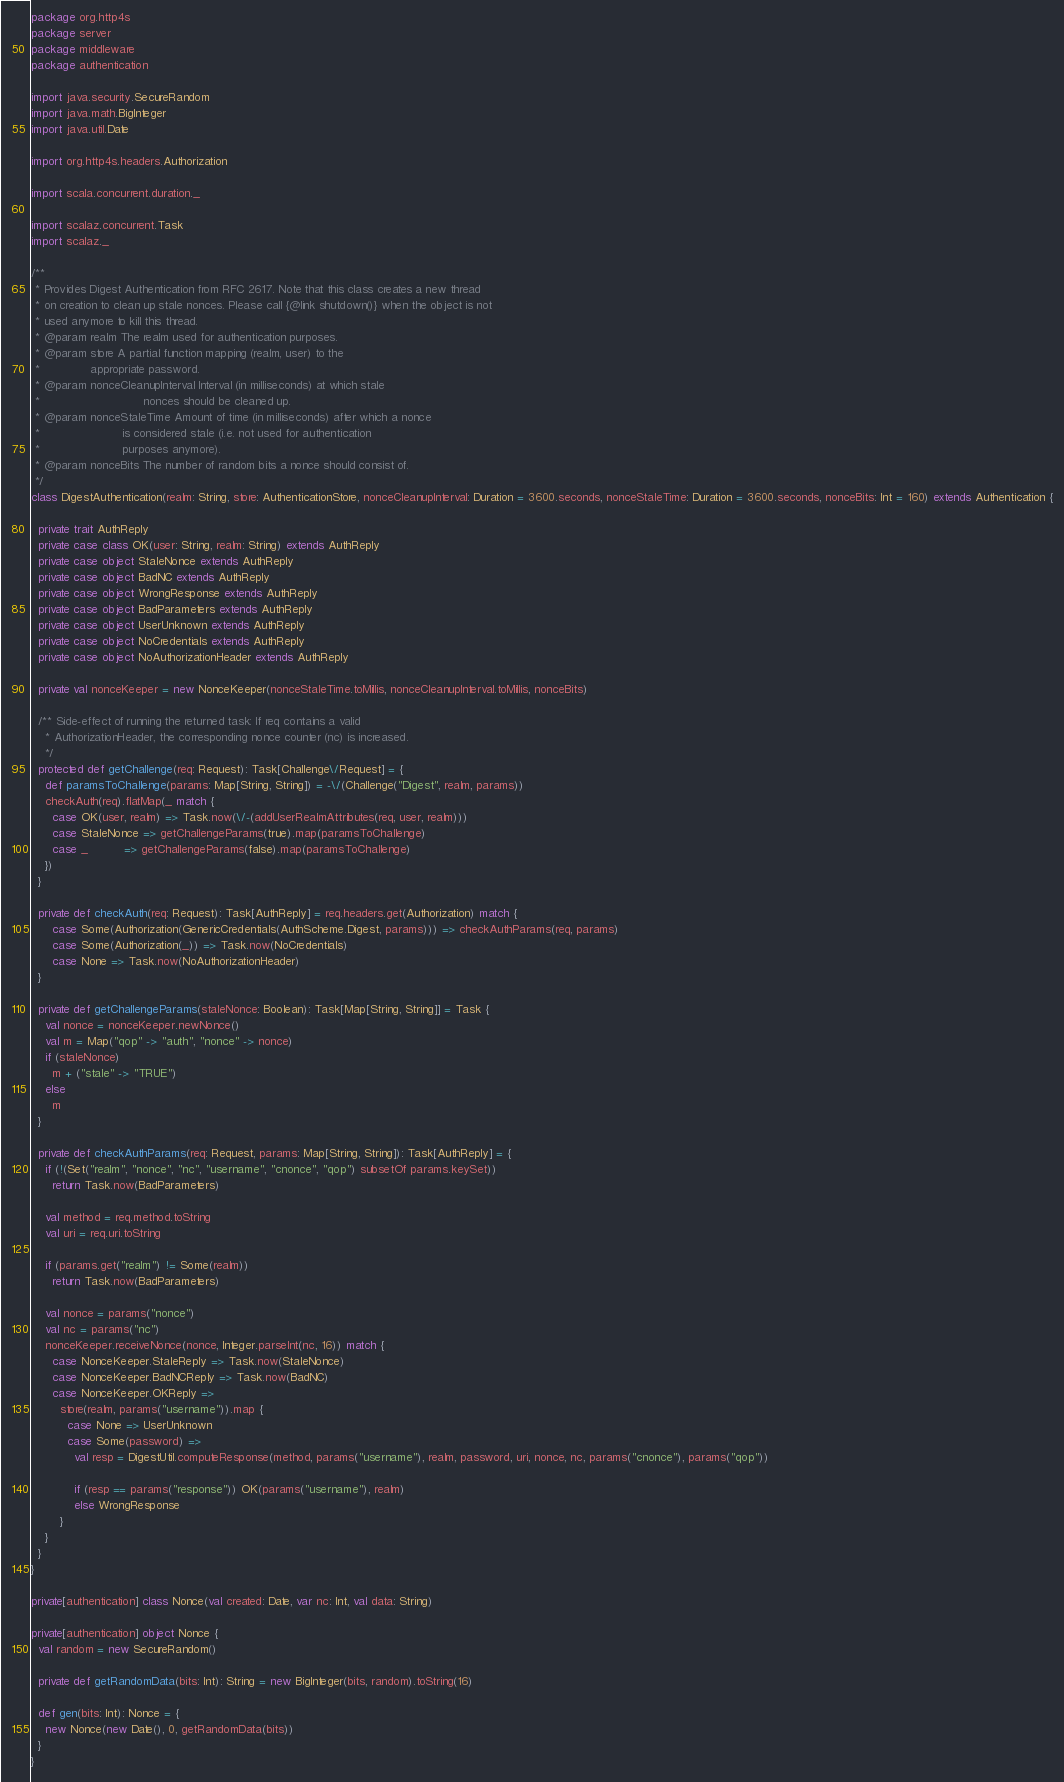<code> <loc_0><loc_0><loc_500><loc_500><_Scala_>package org.http4s
package server
package middleware
package authentication

import java.security.SecureRandom
import java.math.BigInteger
import java.util.Date

import org.http4s.headers.Authorization

import scala.concurrent.duration._

import scalaz.concurrent.Task
import scalaz._

/**
 * Provides Digest Authentication from RFC 2617. Note that this class creates a new thread
 * on creation to clean up stale nonces. Please call {@link shutdown()} when the object is not
 * used anymore to kill this thread.
 * @param realm The realm used for authentication purposes.
 * @param store A partial function mapping (realm, user) to the
 *              appropriate password.
 * @param nonceCleanupInterval Interval (in milliseconds) at which stale
 *                             nonces should be cleaned up.
 * @param nonceStaleTime Amount of time (in milliseconds) after which a nonce
 *                       is considered stale (i.e. not used for authentication
 *                       purposes anymore).
 * @param nonceBits The number of random bits a nonce should consist of.
 */
class DigestAuthentication(realm: String, store: AuthenticationStore, nonceCleanupInterval: Duration = 3600.seconds, nonceStaleTime: Duration = 3600.seconds, nonceBits: Int = 160) extends Authentication {

  private trait AuthReply
  private case class OK(user: String, realm: String) extends AuthReply
  private case object StaleNonce extends AuthReply
  private case object BadNC extends AuthReply
  private case object WrongResponse extends AuthReply
  private case object BadParameters extends AuthReply
  private case object UserUnknown extends AuthReply
  private case object NoCredentials extends AuthReply
  private case object NoAuthorizationHeader extends AuthReply

  private val nonceKeeper = new NonceKeeper(nonceStaleTime.toMillis, nonceCleanupInterval.toMillis, nonceBits)

  /** Side-effect of running the returned task: If req contains a valid
    * AuthorizationHeader, the corresponding nonce counter (nc) is increased.
    */
  protected def getChallenge(req: Request): Task[Challenge\/Request] = {
    def paramsToChallenge(params: Map[String, String]) = -\/(Challenge("Digest", realm, params))
    checkAuth(req).flatMap(_ match {
      case OK(user, realm) => Task.now(\/-(addUserRealmAttributes(req, user, realm)))
      case StaleNonce => getChallengeParams(true).map(paramsToChallenge)
      case _          => getChallengeParams(false).map(paramsToChallenge)
    })
  }

  private def checkAuth(req: Request): Task[AuthReply] = req.headers.get(Authorization) match {
      case Some(Authorization(GenericCredentials(AuthScheme.Digest, params))) => checkAuthParams(req, params)
      case Some(Authorization(_)) => Task.now(NoCredentials)
      case None => Task.now(NoAuthorizationHeader)
  }

  private def getChallengeParams(staleNonce: Boolean): Task[Map[String, String]] = Task {
    val nonce = nonceKeeper.newNonce()
    val m = Map("qop" -> "auth", "nonce" -> nonce)
    if (staleNonce)
      m + ("stale" -> "TRUE")
    else
      m
  }

  private def checkAuthParams(req: Request, params: Map[String, String]): Task[AuthReply] = {
    if (!(Set("realm", "nonce", "nc", "username", "cnonce", "qop") subsetOf params.keySet))
      return Task.now(BadParameters)

    val method = req.method.toString
    val uri = req.uri.toString

    if (params.get("realm") != Some(realm))
      return Task.now(BadParameters)

    val nonce = params("nonce")
    val nc = params("nc")
    nonceKeeper.receiveNonce(nonce, Integer.parseInt(nc, 16)) match {
      case NonceKeeper.StaleReply => Task.now(StaleNonce)
      case NonceKeeper.BadNCReply => Task.now(BadNC)
      case NonceKeeper.OKReply =>
        store(realm, params("username")).map {
          case None => UserUnknown
          case Some(password) =>
            val resp = DigestUtil.computeResponse(method, params("username"), realm, password, uri, nonce, nc, params("cnonce"), params("qop"))

            if (resp == params("response")) OK(params("username"), realm)
            else WrongResponse
        }
    }
  }
}

private[authentication] class Nonce(val created: Date, var nc: Int, val data: String)

private[authentication] object Nonce {
  val random = new SecureRandom()

  private def getRandomData(bits: Int): String = new BigInteger(bits, random).toString(16)

  def gen(bits: Int): Nonce = {
    new Nonce(new Date(), 0, getRandomData(bits))
  }
}
</code> 